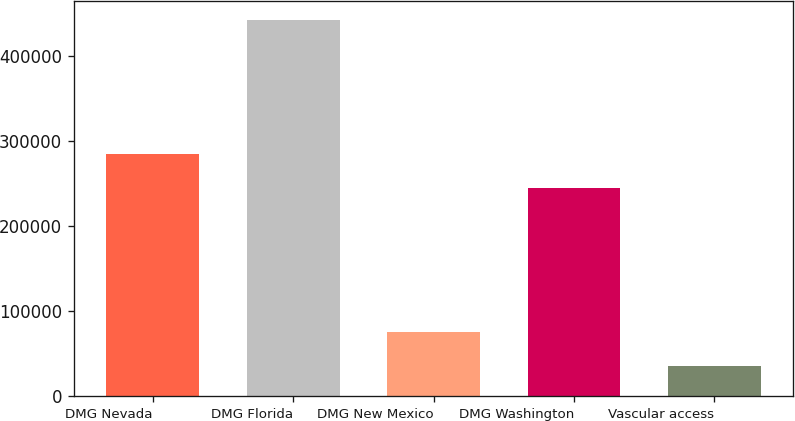Convert chart. <chart><loc_0><loc_0><loc_500><loc_500><bar_chart><fcel>DMG Nevada<fcel>DMG Florida<fcel>DMG New Mexico<fcel>DMG Washington<fcel>Vascular access<nl><fcel>285316<fcel>442835<fcel>75509.9<fcel>244502<fcel>34696<nl></chart> 